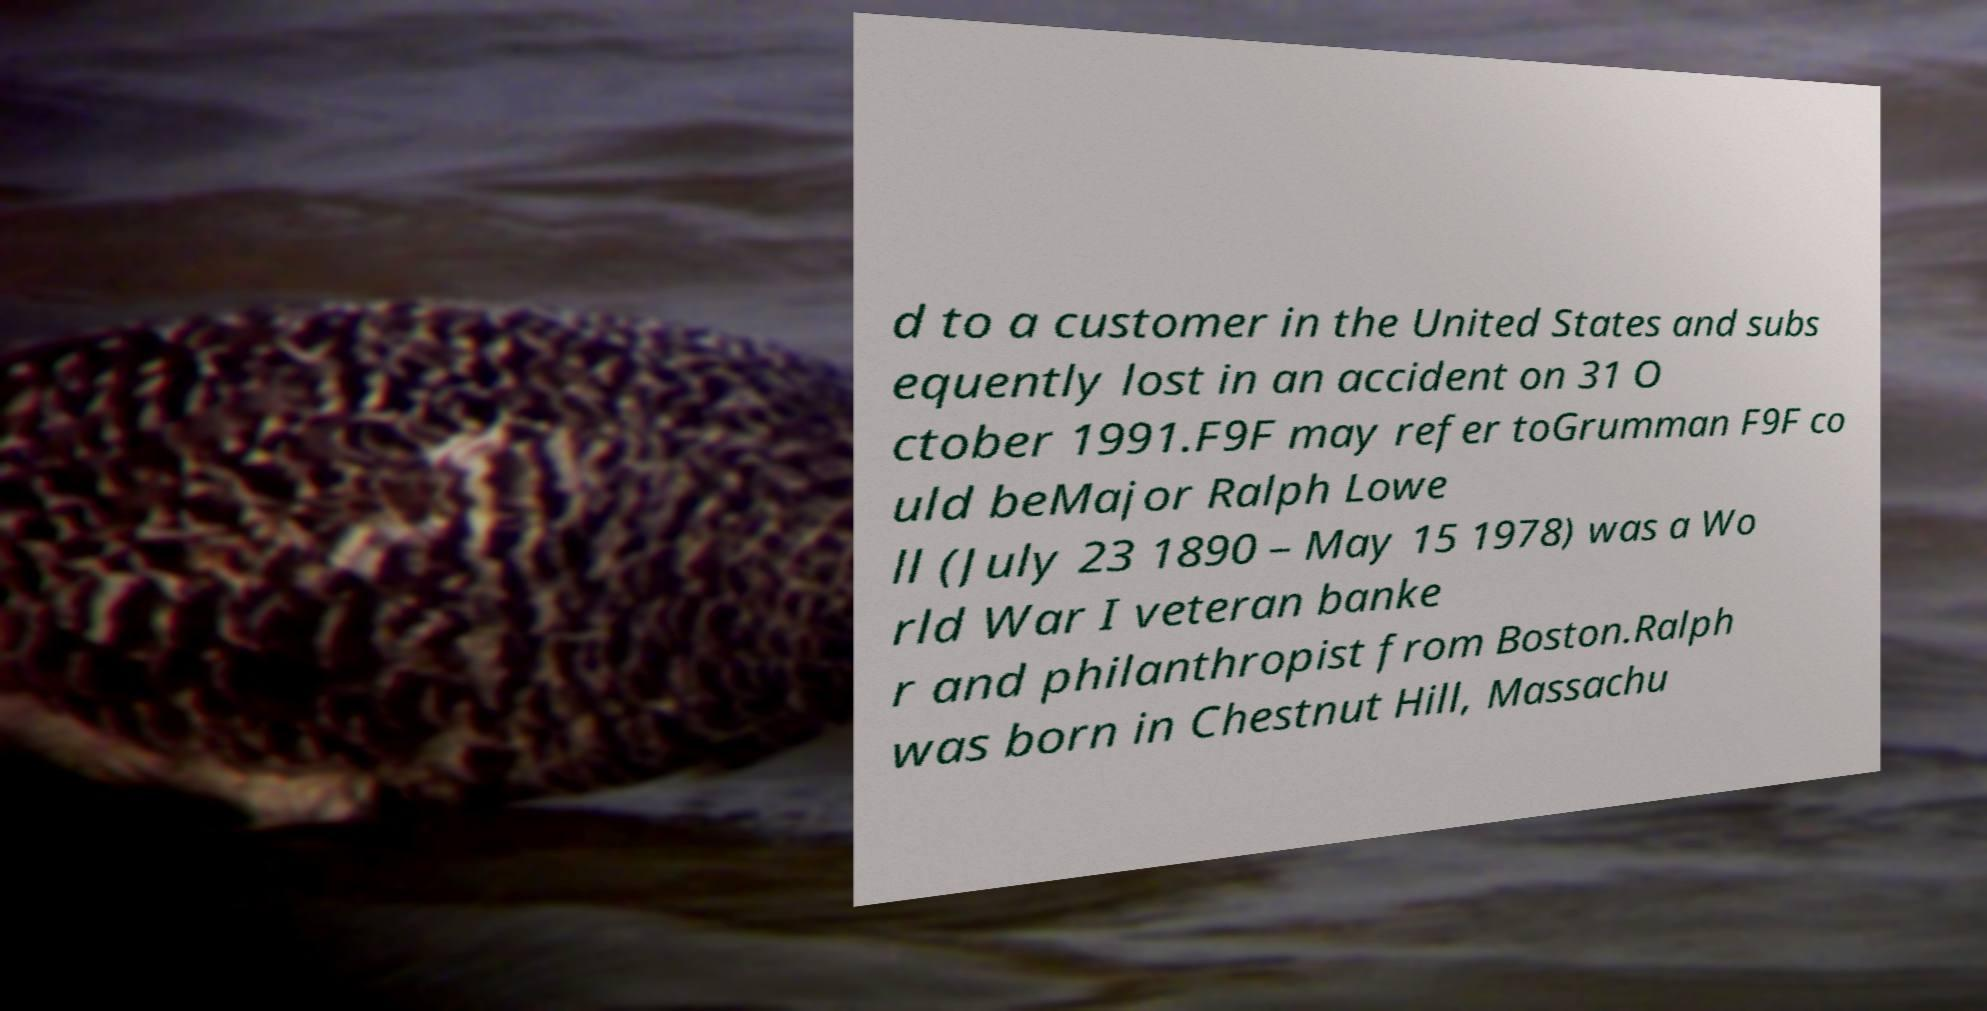Please identify and transcribe the text found in this image. d to a customer in the United States and subs equently lost in an accident on 31 O ctober 1991.F9F may refer toGrumman F9F co uld beMajor Ralph Lowe ll (July 23 1890 – May 15 1978) was a Wo rld War I veteran banke r and philanthropist from Boston.Ralph was born in Chestnut Hill, Massachu 